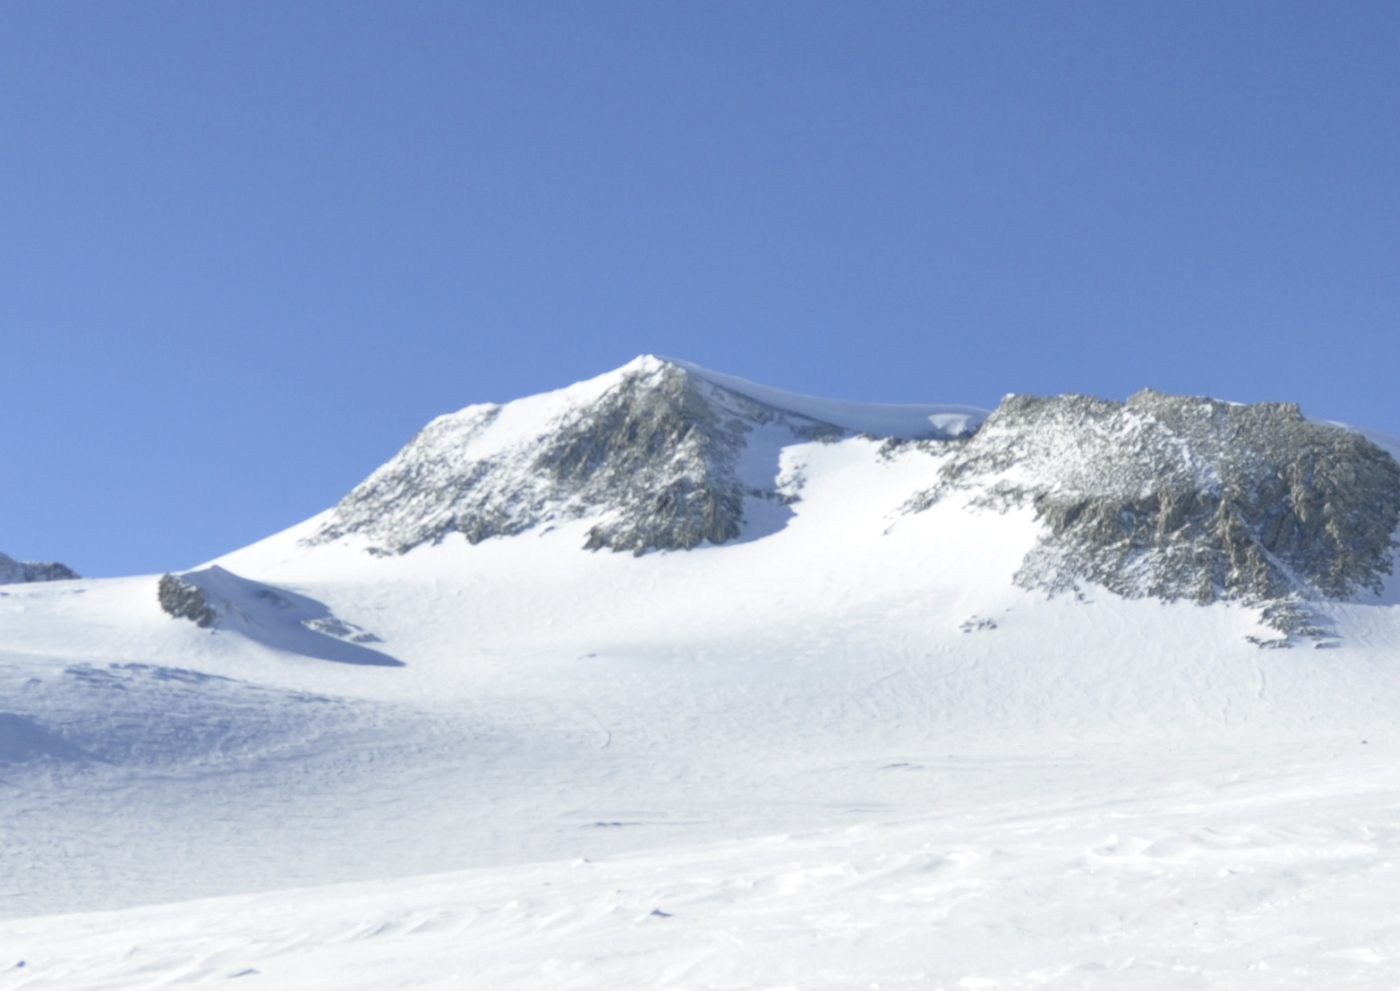Can you describe the significance of Vinson Massif in the context of Antarctic exploration? Vinson Massif holds a prominent place in the history of Antarctic exploration. As the highest peak on the continent, reaching 4,892 meters (16,050 feet), it represents a significant challenge to mountaineers. First climbed in 1966 by an American expedition led by Nicholas Clinch, the peak has since become a coveted goal for climbers aiming to complete the Seven Summits—the highest peak on each of the seven continents. Its remote location, severe weather conditions, and extreme cold make it a demanding climb, emphasizing the resilience and determination required to explore Antarctica. What kind of wildlife might one encounter near Vinson Massif? Due to the harsh and extreme climate of Antarctica, particularly in the inland and high-altitude areas such as Vinson Massif, wildlife is scarce. However, closer to the coast, one might encounter species like Antarctic krill, a variety of seabirds including the Antarctic petrel, and several species of seals and penguins, such as the Emperor and Adélie penguins. These animals are well-adapted to the cold and rely heavily on the ocean and coastal regions for food and breeding grounds, far from the icy heights of Vinson Massif. 